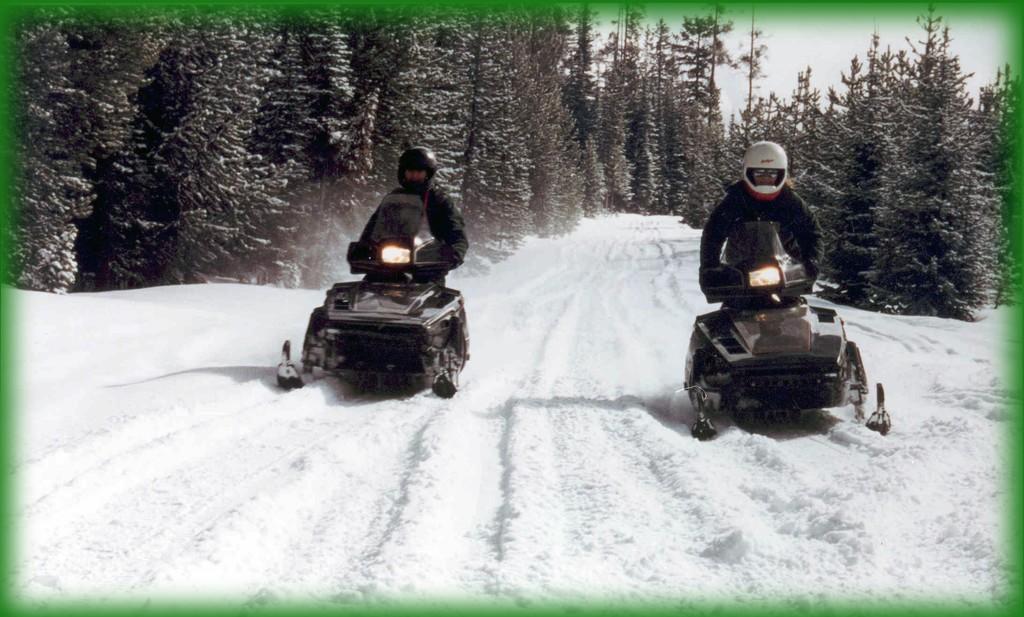Could you give a brief overview of what you see in this image? In this picture there are people in the image, they are driving vehicles on the snow floor and there are trees in the background area of the image. 